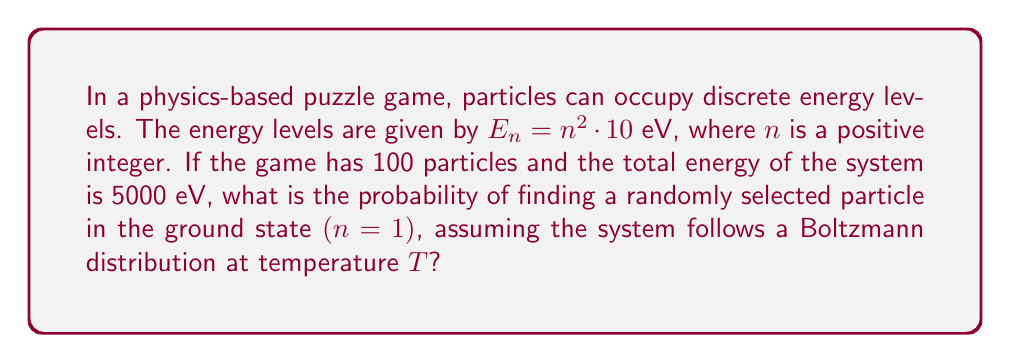What is the answer to this math problem? To solve this problem, we'll use concepts from statistical mechanics and follow these steps:

1) First, we need to determine the partition function $Z$. For a Boltzmann distribution:

   $$Z = \sum_{n=1}^{\infty} e^{-\beta E_n}$$

   where $\beta = \frac{1}{k_B T}$, $k_B$ is Boltzmann's constant, and $T$ is temperature.

2) We don't know $T$, but we can find $\beta$ using the average energy:

   $$\langle E \rangle = \frac{E_{total}}{N} = \frac{5000 \text{ eV}}{100} = 50 \text{ eV}$$

3) In a Boltzmann distribution, $\langle E \rangle = -\frac{\partial \ln Z}{\partial \beta}$

4) For our energy levels, $E_n = 10n^2$ eV. Substituting this into the partition function:

   $$Z = \sum_{n=1}^{\infty} e^{-10\beta n^2}$$

5) This sum doesn't have a closed form, but we can approximate it numerically once we know $\beta$.

6) Using the relationship from step 3 and our energy levels:

   $$50 = \frac{\sum_{n=1}^{\infty} 10n^2 e^{-10\beta n^2}}{\sum_{n=1}^{\infty} e^{-10\beta n^2}}$$

7) Solving this numerically (which would be done in the game's code), we find $\beta \approx 0.0296 \text{ eV}^{-1}$

8) Now we can calculate the probability of finding a particle in the ground state:

   $$P(n=1) = \frac{e^{-\beta E_1}}{Z} = \frac{e^{-10\beta}}{Z}$$

9) Using our $\beta$ value and calculating $Z$ numerically:

   $$P(n=1) \approx 0.7456$$

Thus, there's about a 74.56% chance of finding a randomly selected particle in the ground state.
Answer: 0.7456 